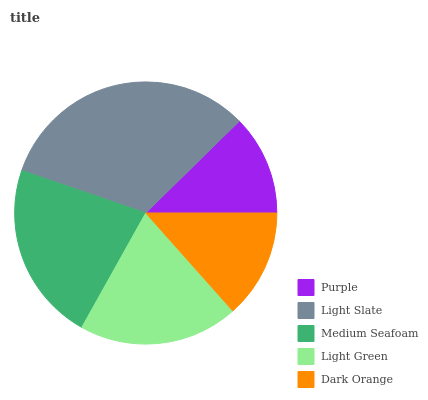Is Purple the minimum?
Answer yes or no. Yes. Is Light Slate the maximum?
Answer yes or no. Yes. Is Medium Seafoam the minimum?
Answer yes or no. No. Is Medium Seafoam the maximum?
Answer yes or no. No. Is Light Slate greater than Medium Seafoam?
Answer yes or no. Yes. Is Medium Seafoam less than Light Slate?
Answer yes or no. Yes. Is Medium Seafoam greater than Light Slate?
Answer yes or no. No. Is Light Slate less than Medium Seafoam?
Answer yes or no. No. Is Light Green the high median?
Answer yes or no. Yes. Is Light Green the low median?
Answer yes or no. Yes. Is Light Slate the high median?
Answer yes or no. No. Is Dark Orange the low median?
Answer yes or no. No. 